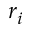<formula> <loc_0><loc_0><loc_500><loc_500>r _ { i }</formula> 